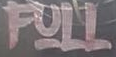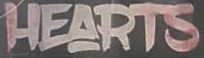Identify the words shown in these images in order, separated by a semicolon. FULL; HEARTS 